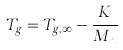Convert formula to latex. <formula><loc_0><loc_0><loc_500><loc_500>T _ { g } = T _ { g , \infty } - \frac { K } { M _ { n } }</formula> 